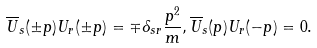Convert formula to latex. <formula><loc_0><loc_0><loc_500><loc_500>\overline { U } _ { s } ( \pm p ) U _ { r } ( \pm p ) = \mp \delta _ { s r } \frac { p ^ { 2 } } { m } , \overline { U } _ { s } ( p ) U _ { r } ( - p ) = 0 .</formula> 